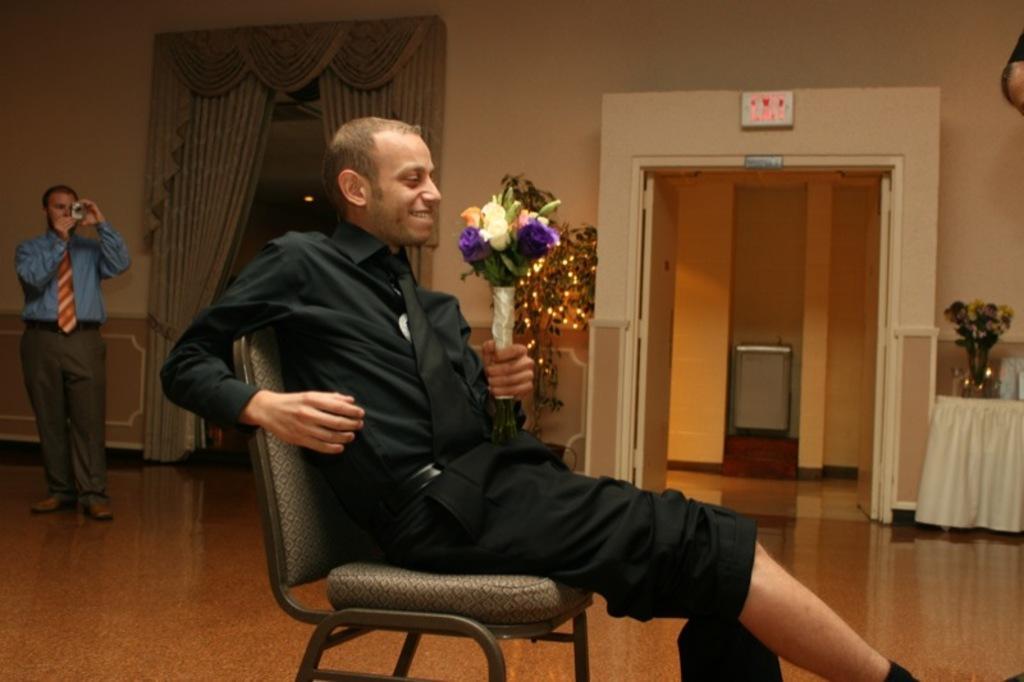Can you describe this image briefly? In this picture there is a man sitting on the chair. He is holding a flower bouquet in his hand. There is a person who is holding a camera in his hand. There is a flower bouquet on the table. There is a plant with some lights. There is a grey curtain at the background. 